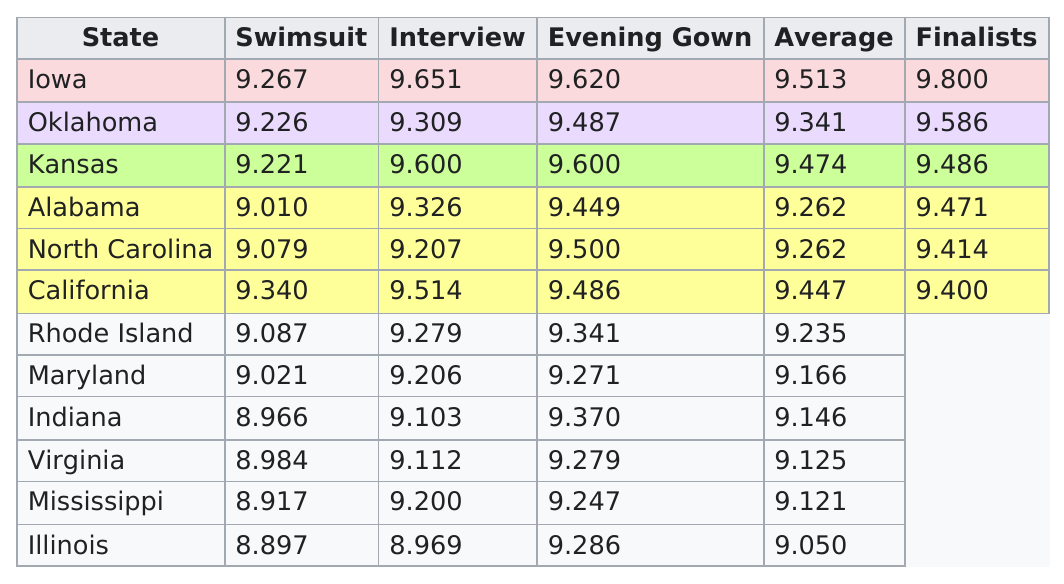Identify some key points in this picture. The average score of Miss Oklahoma was 9.341. The finalist who received the same score in evening gown as in interview is Kansas. The total number of points scored in the three rounds in Kansas is 28.421... The swimsuit competition was held in California, and it was won by the person who scored the most points. The top six finalists with the highest average score are: Iowa. 